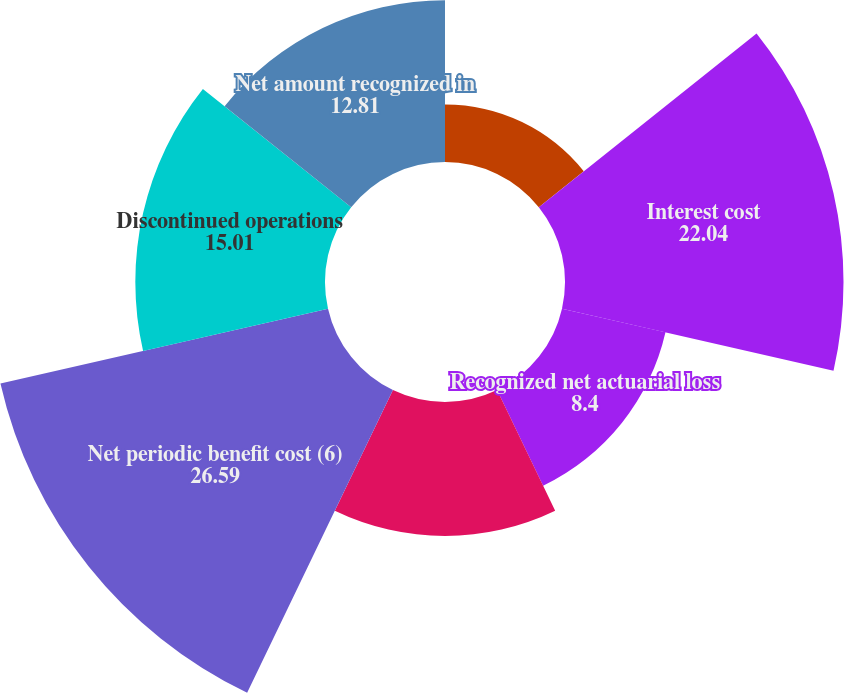<chart> <loc_0><loc_0><loc_500><loc_500><pie_chart><fcel>Service cost<fcel>Interest cost<fcel>Recognized net actuarial loss<fcel>Amortization of prior service<fcel>Net periodic benefit cost (6)<fcel>Discontinued operations<fcel>Net amount recognized in<nl><fcel>4.55%<fcel>22.04%<fcel>8.4%<fcel>10.6%<fcel>26.59%<fcel>15.01%<fcel>12.81%<nl></chart> 